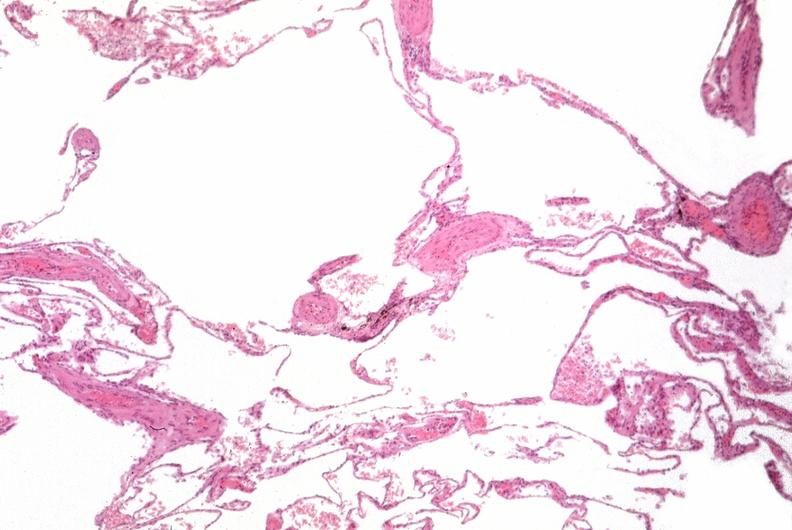how many antitrypsin does this image show lung, emphysema, alpha-deficiency?
Answer the question using a single word or phrase. 1 